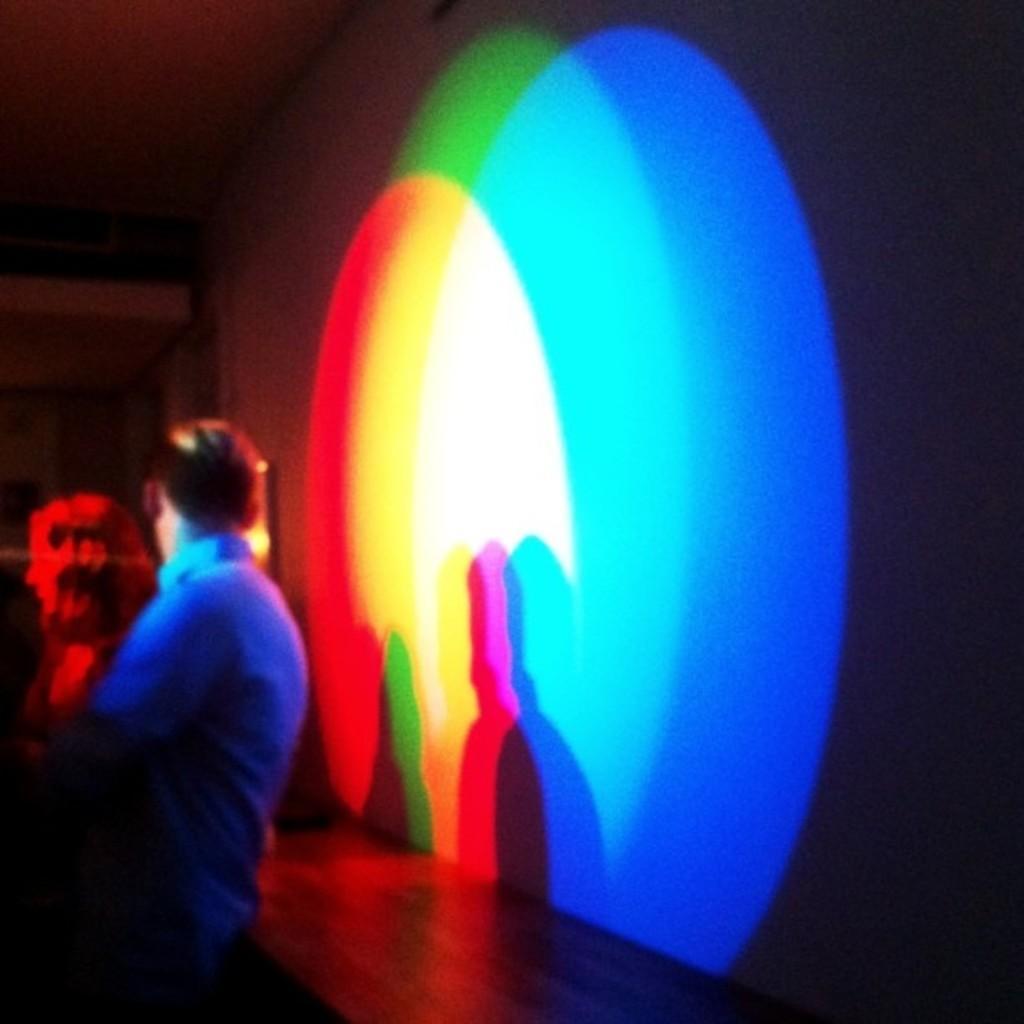Describe this image in one or two sentences. This picture is slightly blurred, where we can see two persons are standing. Here we can see the red, yellow, white, green and blue color lights projected on the wall. The background of the image is dark. 